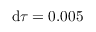<formula> <loc_0><loc_0><loc_500><loc_500>d \tau = 0 . 0 0 5</formula> 